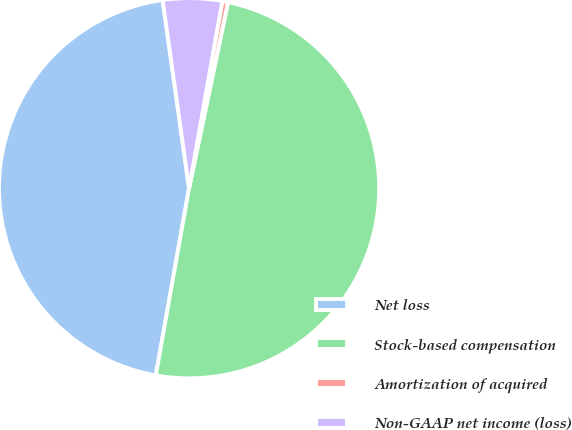Convert chart. <chart><loc_0><loc_0><loc_500><loc_500><pie_chart><fcel>Net loss<fcel>Stock-based compensation<fcel>Amortization of acquired<fcel>Non-GAAP net income (loss)<nl><fcel>44.98%<fcel>49.51%<fcel>0.49%<fcel>5.02%<nl></chart> 